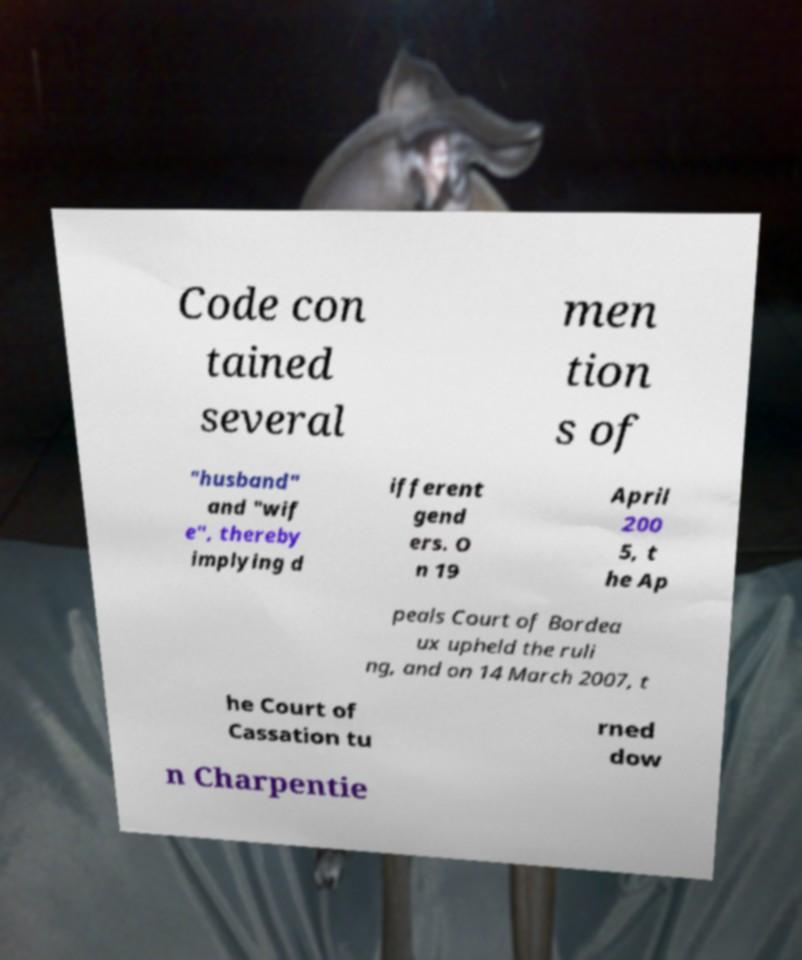Can you accurately transcribe the text from the provided image for me? Code con tained several men tion s of "husband" and "wif e", thereby implying d ifferent gend ers. O n 19 April 200 5, t he Ap peals Court of Bordea ux upheld the ruli ng, and on 14 March 2007, t he Court of Cassation tu rned dow n Charpentie 